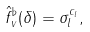Convert formula to latex. <formula><loc_0><loc_0><loc_500><loc_500>\hat { f } ^ { \flat } _ { v } ( \delta ) = \sigma _ { l } ^ { c _ { l } } ,</formula> 